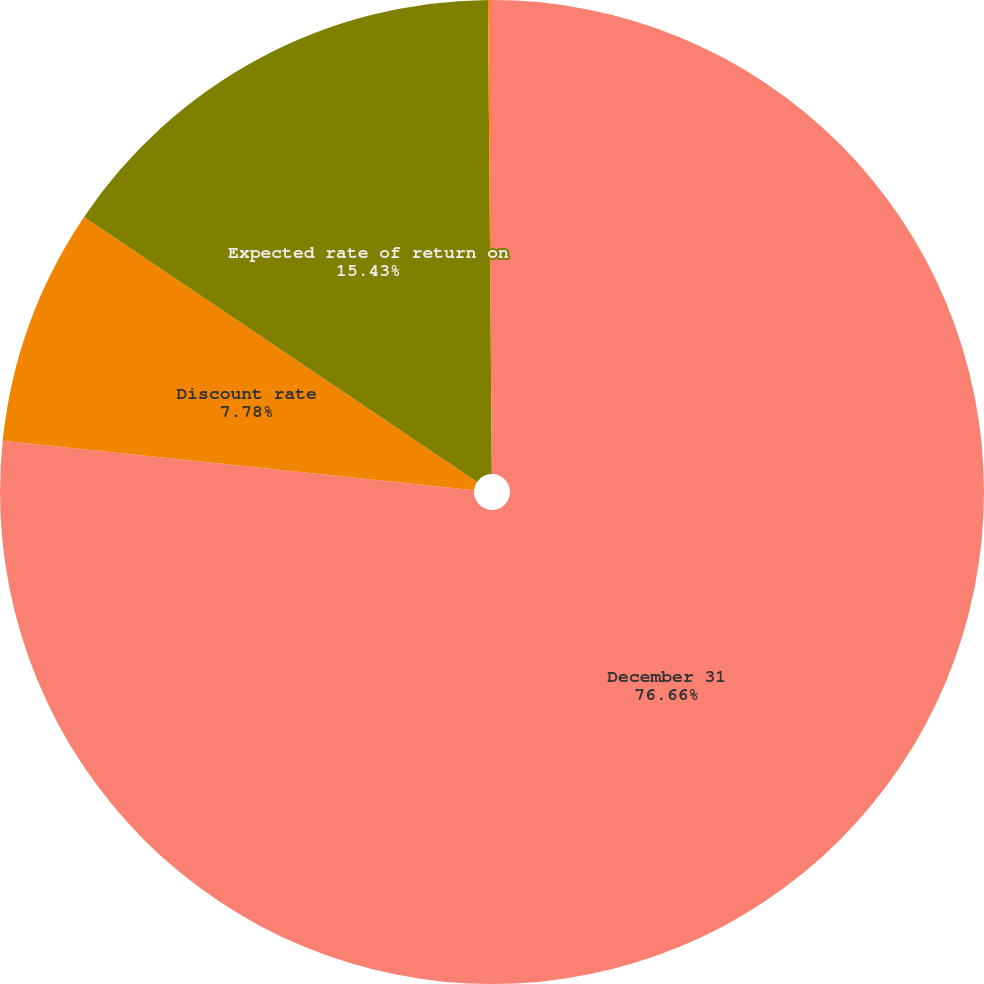Convert chart. <chart><loc_0><loc_0><loc_500><loc_500><pie_chart><fcel>December 31<fcel>Discount rate<fcel>Expected rate of return on<fcel>Salary growth rate<nl><fcel>76.66%<fcel>7.78%<fcel>15.43%<fcel>0.13%<nl></chart> 